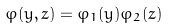<formula> <loc_0><loc_0><loc_500><loc_500>\varphi ( y , z ) = { \varphi } _ { 1 } ( y ) { \varphi } _ { 2 } ( z )</formula> 